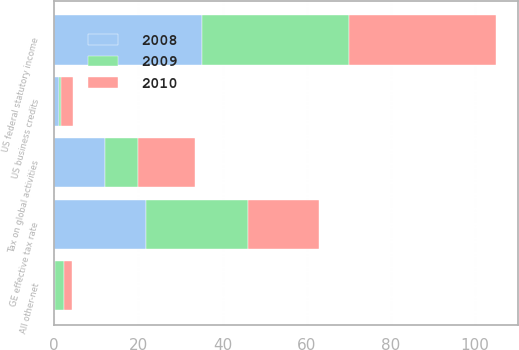Convert chart to OTSL. <chart><loc_0><loc_0><loc_500><loc_500><stacked_bar_chart><ecel><fcel>US federal statutory income<fcel>Tax on global activities<fcel>US business credits<fcel>All other-net<fcel>GE effective tax rate<nl><fcel>2010<fcel>35<fcel>13.5<fcel>2.8<fcel>1.9<fcel>16.8<nl><fcel>2008<fcel>35<fcel>12<fcel>1.1<fcel>0.1<fcel>21.8<nl><fcel>2009<fcel>35<fcel>8<fcel>0.5<fcel>2.3<fcel>24.2<nl></chart> 